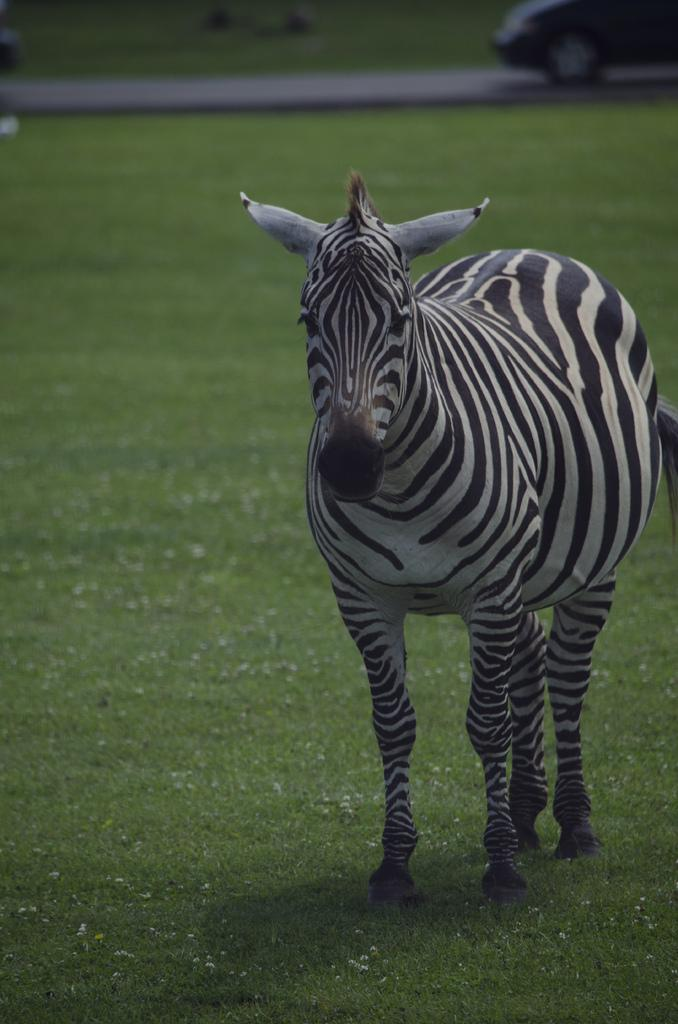What animal can be seen in the image? There is a zebra in the image. What is the zebra standing on? The zebra is standing on a grass surface. What else can be seen in the image besides the zebra? There is a road visible in the image, and a half part of a car is present on the road. What color is the car in the image? The car is black in color. What type of chair can be seen in the image? There is no chair present in the image. What system is responsible for the zebra's stripes in the image? The image does not provide information about the biological or genetic system responsible for the zebra's stripes. 